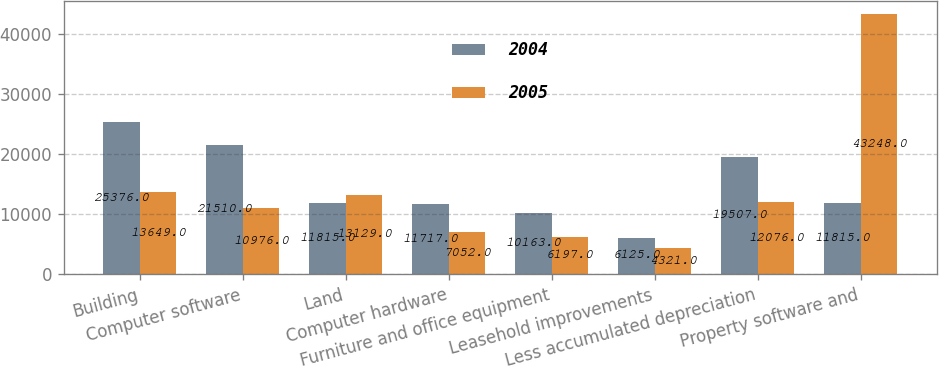Convert chart. <chart><loc_0><loc_0><loc_500><loc_500><stacked_bar_chart><ecel><fcel>Building<fcel>Computer software<fcel>Land<fcel>Computer hardware<fcel>Furniture and office equipment<fcel>Leasehold improvements<fcel>Less accumulated depreciation<fcel>Property software and<nl><fcel>2004<fcel>25376<fcel>21510<fcel>11815<fcel>11717<fcel>10163<fcel>6125<fcel>19507<fcel>11815<nl><fcel>2005<fcel>13649<fcel>10976<fcel>13129<fcel>7052<fcel>6197<fcel>4321<fcel>12076<fcel>43248<nl></chart> 